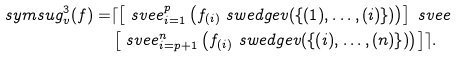Convert formula to latex. <formula><loc_0><loc_0><loc_500><loc_500>\ s y m s u g ^ { 3 } _ { v } ( f ) = & \lceil \left [ \ s v e e _ { i = 1 } ^ { p } \left ( f _ { ( i ) } \ s w e d g e v ( \{ ( 1 ) , \dots , ( i ) \} ) \right ) \right ] \ s v e e \\ & \left [ \ s v e e _ { i = p + 1 } ^ { n } \left ( f _ { ( i ) } \ s w e d g e v ( \{ ( i ) , \dots , ( n ) \} ) \right ) \right ] \rceil .</formula> 